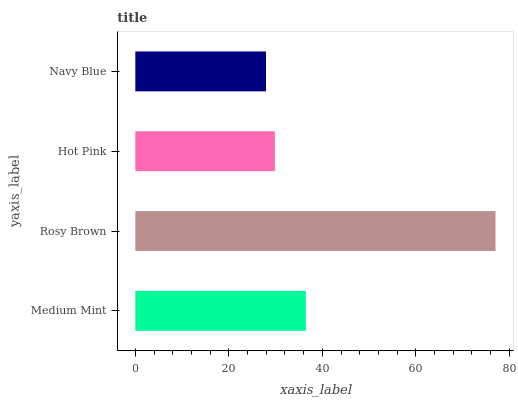Is Navy Blue the minimum?
Answer yes or no. Yes. Is Rosy Brown the maximum?
Answer yes or no. Yes. Is Hot Pink the minimum?
Answer yes or no. No. Is Hot Pink the maximum?
Answer yes or no. No. Is Rosy Brown greater than Hot Pink?
Answer yes or no. Yes. Is Hot Pink less than Rosy Brown?
Answer yes or no. Yes. Is Hot Pink greater than Rosy Brown?
Answer yes or no. No. Is Rosy Brown less than Hot Pink?
Answer yes or no. No. Is Medium Mint the high median?
Answer yes or no. Yes. Is Hot Pink the low median?
Answer yes or no. Yes. Is Hot Pink the high median?
Answer yes or no. No. Is Rosy Brown the low median?
Answer yes or no. No. 